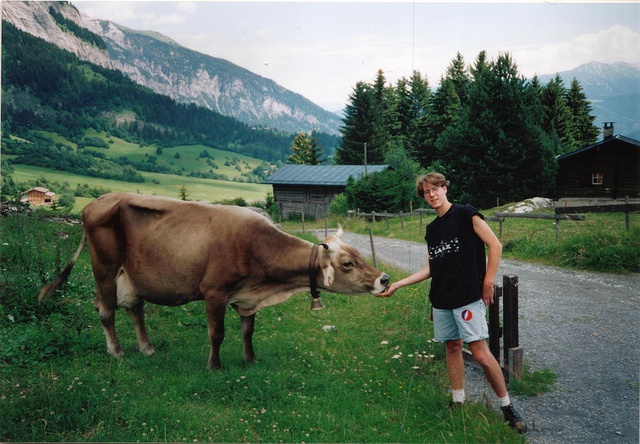Describe the objects in this image and their specific colors. I can see cow in ivory, black, maroon, and gray tones and people in ivory, black, brown, darkgray, and gray tones in this image. 